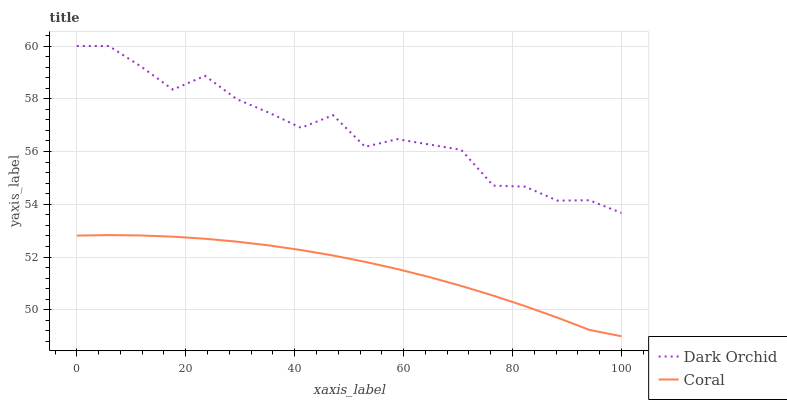Does Coral have the minimum area under the curve?
Answer yes or no. Yes. Does Dark Orchid have the maximum area under the curve?
Answer yes or no. Yes. Does Dark Orchid have the minimum area under the curve?
Answer yes or no. No. Is Coral the smoothest?
Answer yes or no. Yes. Is Dark Orchid the roughest?
Answer yes or no. Yes. Is Dark Orchid the smoothest?
Answer yes or no. No. Does Dark Orchid have the lowest value?
Answer yes or no. No. Is Coral less than Dark Orchid?
Answer yes or no. Yes. Is Dark Orchid greater than Coral?
Answer yes or no. Yes. Does Coral intersect Dark Orchid?
Answer yes or no. No. 